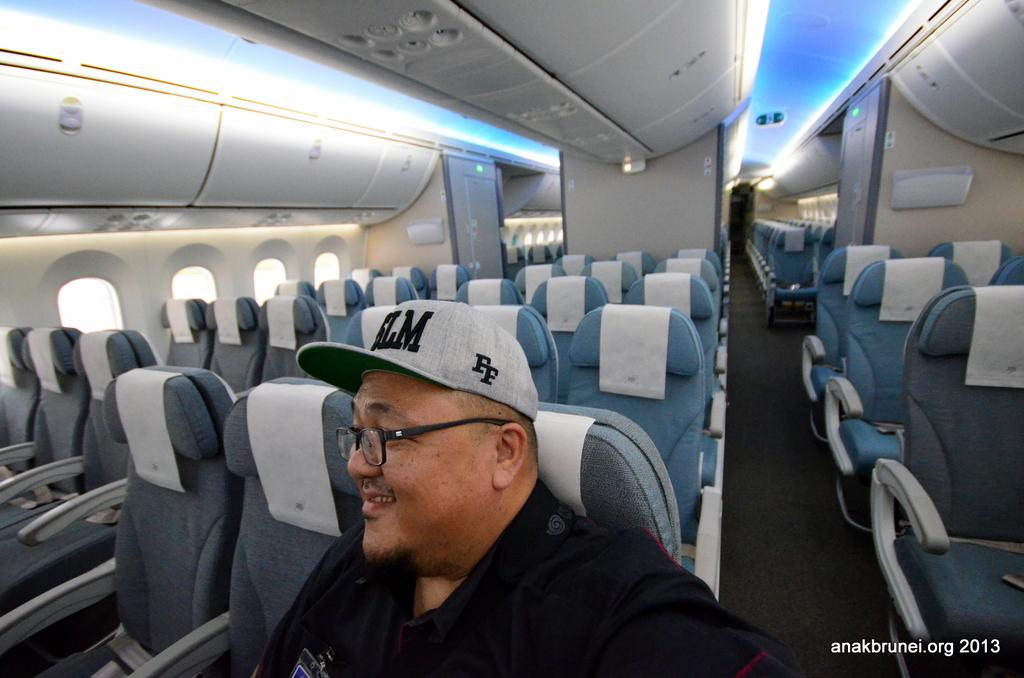<image>
Present a compact description of the photo's key features. Seats on a plane with one person in them with a gray hat that says FF on the side 